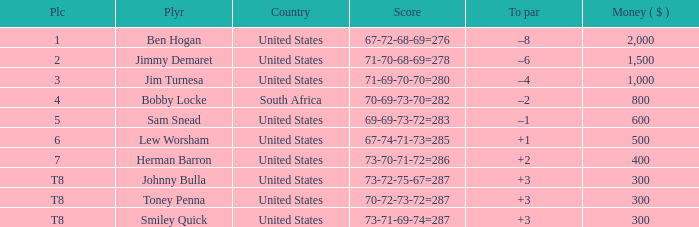What is the Place of the Player with Money greater than 300 and a Score of 71-69-70-70=280? 3.0. 